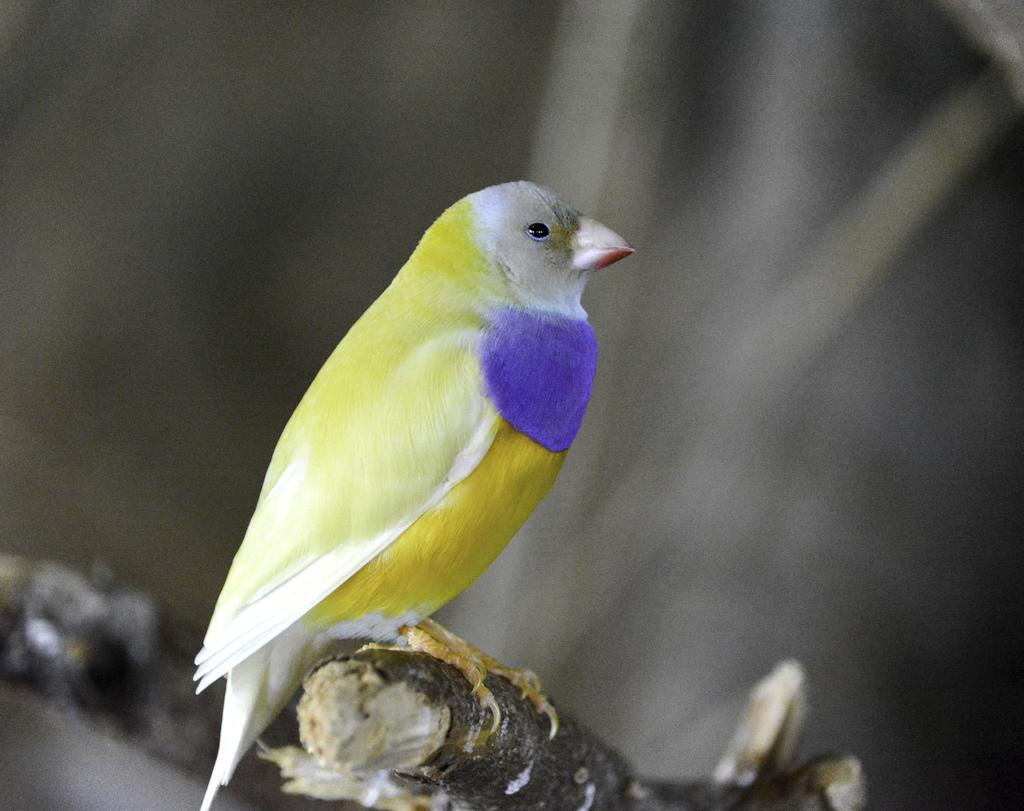What type of animal is in the image? There is a bird in the image. How is the bird positioned in the image? The bird is on a stick. Can you describe the background of the image? The background of the image is blurry. What type of volleyball game is being played in the background of the image? There is no volleyball game present in the image; it features a bird on a stick with a blurry background. 